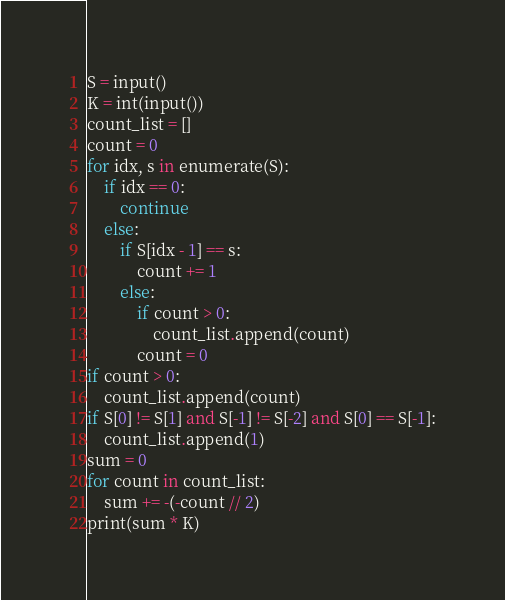<code> <loc_0><loc_0><loc_500><loc_500><_Python_>S = input()
K = int(input())
count_list = []
count = 0
for idx, s in enumerate(S):
    if idx == 0:
        continue
    else:
        if S[idx - 1] == s:
            count += 1
        else:
            if count > 0:
                count_list.append(count)
            count = 0
if count > 0:
    count_list.append(count)
if S[0] != S[1] and S[-1] != S[-2] and S[0] == S[-1]:
    count_list.append(1)
sum = 0
for count in count_list:
    sum += -(-count // 2)
print(sum * K)</code> 